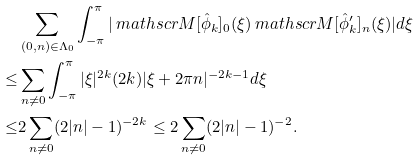Convert formula to latex. <formula><loc_0><loc_0><loc_500><loc_500>& \sum _ { ( 0 , n ) \in \Lambda _ { 0 } } \int _ { - \pi } ^ { \pi } | \ m a t h s c r { M } [ \hat { \phi } _ { k } ] _ { 0 } ( \xi ) \ m a t h s c r { M } [ \hat { \phi } ^ { \prime } _ { k } ] _ { n } ( \xi ) | d \xi \\ \leq & \sum _ { n \neq 0 } \int _ { - \pi } ^ { \pi } | \xi | ^ { 2 k } ( 2 k ) | \xi + 2 \pi n | ^ { - 2 k - 1 } d \xi \\ \leq & 2 \sum _ { n \neq 0 } ( 2 | n | - 1 ) ^ { - 2 k } \leq 2 \sum _ { n \neq 0 } ( 2 | n | - 1 ) ^ { - 2 } .</formula> 